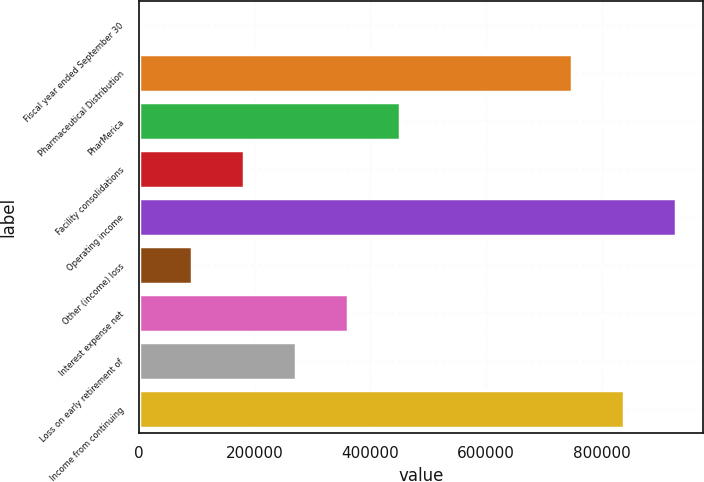<chart> <loc_0><loc_0><loc_500><loc_500><bar_chart><fcel>Fiscal year ended September 30<fcel>Pharmaceutical Distribution<fcel>PharMerica<fcel>Facility consolidations<fcel>Operating income<fcel>Other (income) loss<fcel>Interest expense net<fcel>Loss on early retirement of<fcel>Income from continuing<nl><fcel>2004<fcel>748625<fcel>451482<fcel>181795<fcel>928416<fcel>91899.5<fcel>361586<fcel>271690<fcel>838520<nl></chart> 